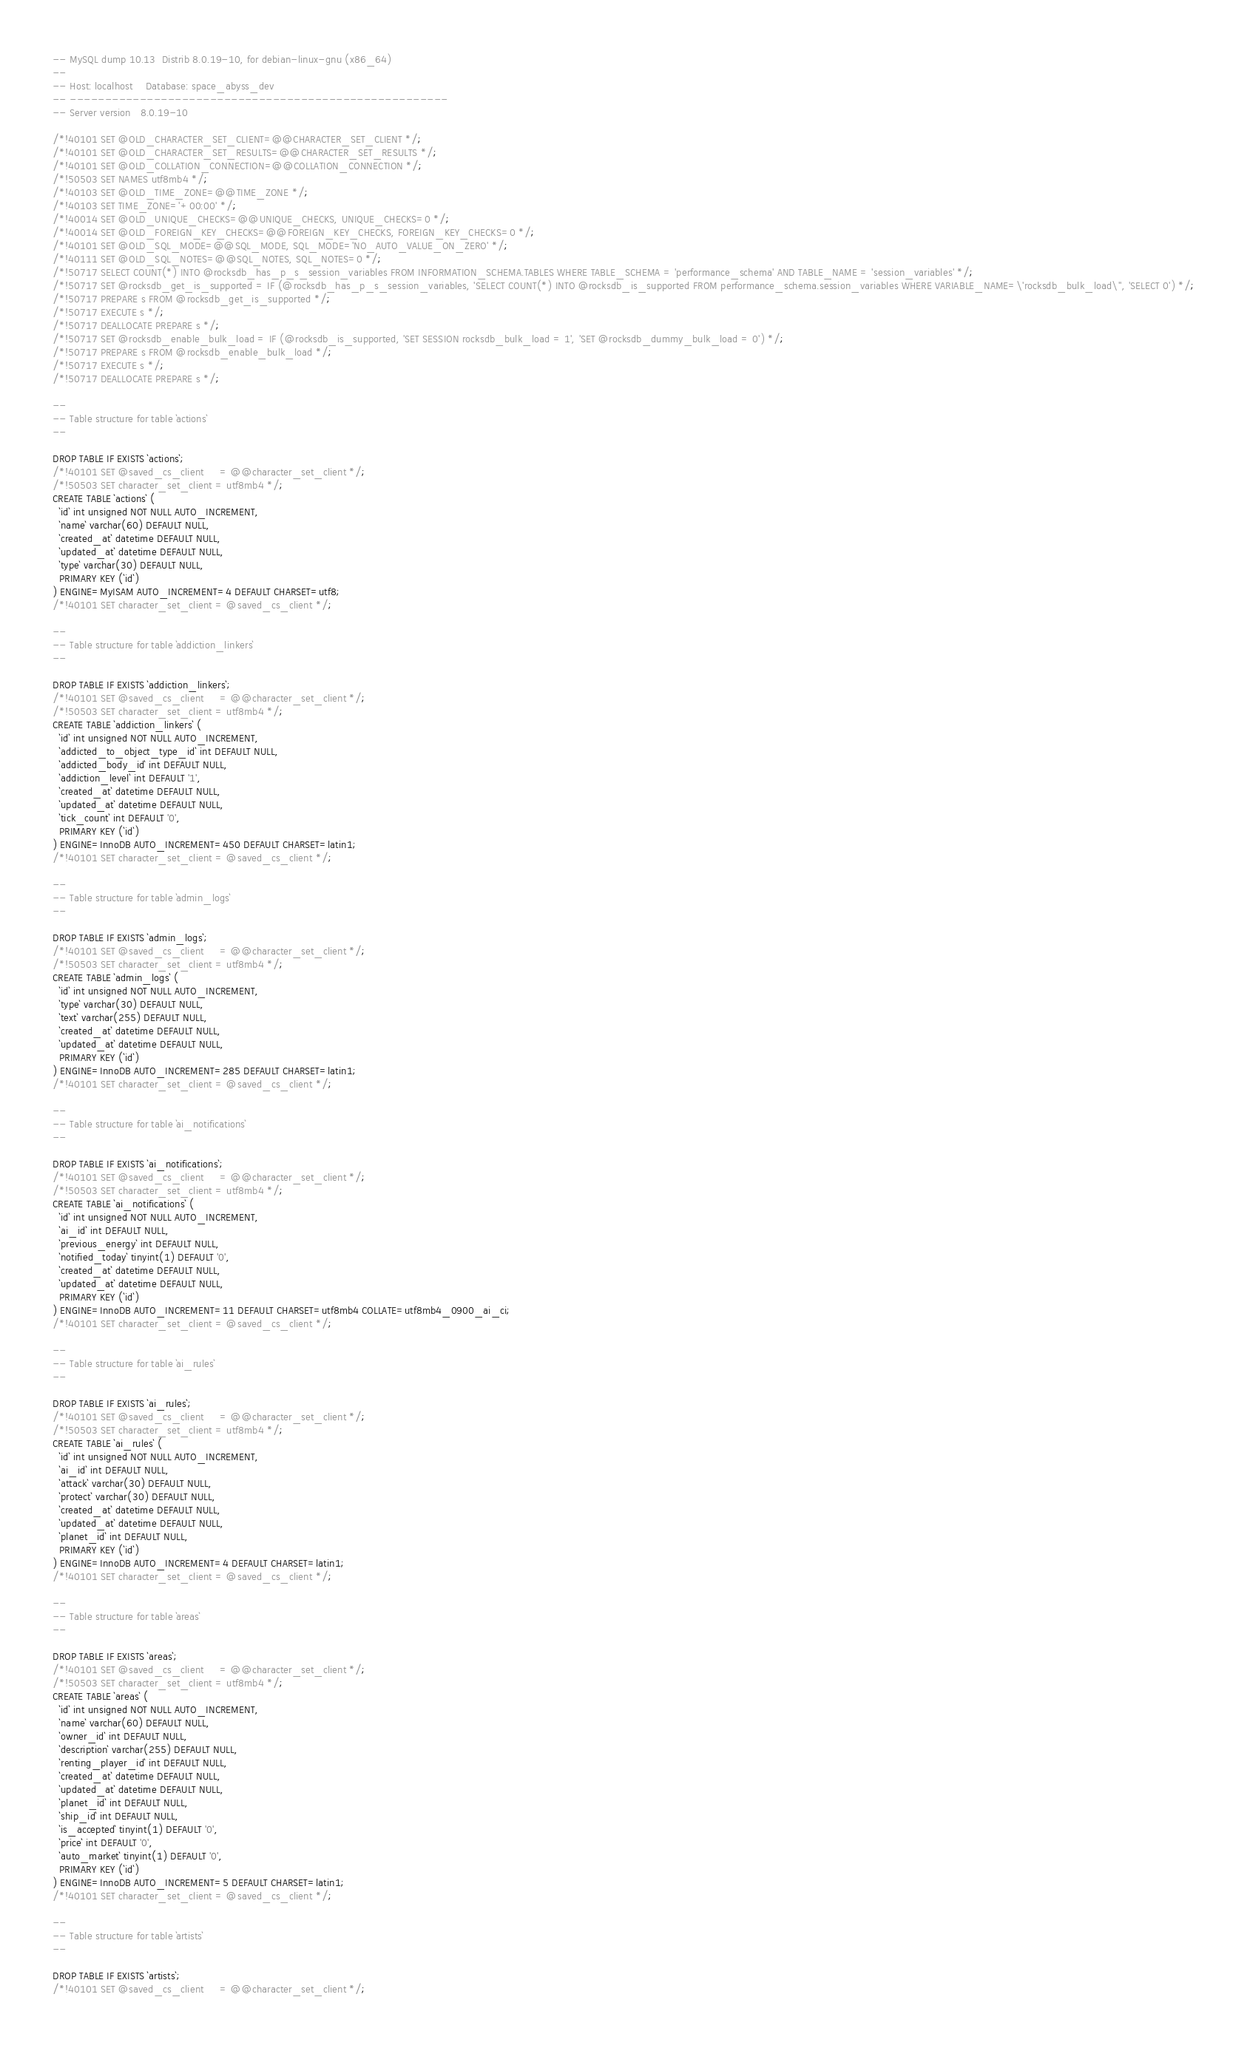<code> <loc_0><loc_0><loc_500><loc_500><_SQL_>-- MySQL dump 10.13  Distrib 8.0.19-10, for debian-linux-gnu (x86_64)
--
-- Host: localhost    Database: space_abyss_dev
-- ------------------------------------------------------
-- Server version	8.0.19-10

/*!40101 SET @OLD_CHARACTER_SET_CLIENT=@@CHARACTER_SET_CLIENT */;
/*!40101 SET @OLD_CHARACTER_SET_RESULTS=@@CHARACTER_SET_RESULTS */;
/*!40101 SET @OLD_COLLATION_CONNECTION=@@COLLATION_CONNECTION */;
/*!50503 SET NAMES utf8mb4 */;
/*!40103 SET @OLD_TIME_ZONE=@@TIME_ZONE */;
/*!40103 SET TIME_ZONE='+00:00' */;
/*!40014 SET @OLD_UNIQUE_CHECKS=@@UNIQUE_CHECKS, UNIQUE_CHECKS=0 */;
/*!40014 SET @OLD_FOREIGN_KEY_CHECKS=@@FOREIGN_KEY_CHECKS, FOREIGN_KEY_CHECKS=0 */;
/*!40101 SET @OLD_SQL_MODE=@@SQL_MODE, SQL_MODE='NO_AUTO_VALUE_ON_ZERO' */;
/*!40111 SET @OLD_SQL_NOTES=@@SQL_NOTES, SQL_NOTES=0 */;
/*!50717 SELECT COUNT(*) INTO @rocksdb_has_p_s_session_variables FROM INFORMATION_SCHEMA.TABLES WHERE TABLE_SCHEMA = 'performance_schema' AND TABLE_NAME = 'session_variables' */;
/*!50717 SET @rocksdb_get_is_supported = IF (@rocksdb_has_p_s_session_variables, 'SELECT COUNT(*) INTO @rocksdb_is_supported FROM performance_schema.session_variables WHERE VARIABLE_NAME=\'rocksdb_bulk_load\'', 'SELECT 0') */;
/*!50717 PREPARE s FROM @rocksdb_get_is_supported */;
/*!50717 EXECUTE s */;
/*!50717 DEALLOCATE PREPARE s */;
/*!50717 SET @rocksdb_enable_bulk_load = IF (@rocksdb_is_supported, 'SET SESSION rocksdb_bulk_load = 1', 'SET @rocksdb_dummy_bulk_load = 0') */;
/*!50717 PREPARE s FROM @rocksdb_enable_bulk_load */;
/*!50717 EXECUTE s */;
/*!50717 DEALLOCATE PREPARE s */;

--
-- Table structure for table `actions`
--

DROP TABLE IF EXISTS `actions`;
/*!40101 SET @saved_cs_client     = @@character_set_client */;
/*!50503 SET character_set_client = utf8mb4 */;
CREATE TABLE `actions` (
  `id` int unsigned NOT NULL AUTO_INCREMENT,
  `name` varchar(60) DEFAULT NULL,
  `created_at` datetime DEFAULT NULL,
  `updated_at` datetime DEFAULT NULL,
  `type` varchar(30) DEFAULT NULL,
  PRIMARY KEY (`id`)
) ENGINE=MyISAM AUTO_INCREMENT=4 DEFAULT CHARSET=utf8;
/*!40101 SET character_set_client = @saved_cs_client */;

--
-- Table structure for table `addiction_linkers`
--

DROP TABLE IF EXISTS `addiction_linkers`;
/*!40101 SET @saved_cs_client     = @@character_set_client */;
/*!50503 SET character_set_client = utf8mb4 */;
CREATE TABLE `addiction_linkers` (
  `id` int unsigned NOT NULL AUTO_INCREMENT,
  `addicted_to_object_type_id` int DEFAULT NULL,
  `addicted_body_id` int DEFAULT NULL,
  `addiction_level` int DEFAULT '1',
  `created_at` datetime DEFAULT NULL,
  `updated_at` datetime DEFAULT NULL,
  `tick_count` int DEFAULT '0',
  PRIMARY KEY (`id`)
) ENGINE=InnoDB AUTO_INCREMENT=450 DEFAULT CHARSET=latin1;
/*!40101 SET character_set_client = @saved_cs_client */;

--
-- Table structure for table `admin_logs`
--

DROP TABLE IF EXISTS `admin_logs`;
/*!40101 SET @saved_cs_client     = @@character_set_client */;
/*!50503 SET character_set_client = utf8mb4 */;
CREATE TABLE `admin_logs` (
  `id` int unsigned NOT NULL AUTO_INCREMENT,
  `type` varchar(30) DEFAULT NULL,
  `text` varchar(255) DEFAULT NULL,
  `created_at` datetime DEFAULT NULL,
  `updated_at` datetime DEFAULT NULL,
  PRIMARY KEY (`id`)
) ENGINE=InnoDB AUTO_INCREMENT=285 DEFAULT CHARSET=latin1;
/*!40101 SET character_set_client = @saved_cs_client */;

--
-- Table structure for table `ai_notifications`
--

DROP TABLE IF EXISTS `ai_notifications`;
/*!40101 SET @saved_cs_client     = @@character_set_client */;
/*!50503 SET character_set_client = utf8mb4 */;
CREATE TABLE `ai_notifications` (
  `id` int unsigned NOT NULL AUTO_INCREMENT,
  `ai_id` int DEFAULT NULL,
  `previous_energy` int DEFAULT NULL,
  `notified_today` tinyint(1) DEFAULT '0',
  `created_at` datetime DEFAULT NULL,
  `updated_at` datetime DEFAULT NULL,
  PRIMARY KEY (`id`)
) ENGINE=InnoDB AUTO_INCREMENT=11 DEFAULT CHARSET=utf8mb4 COLLATE=utf8mb4_0900_ai_ci;
/*!40101 SET character_set_client = @saved_cs_client */;

--
-- Table structure for table `ai_rules`
--

DROP TABLE IF EXISTS `ai_rules`;
/*!40101 SET @saved_cs_client     = @@character_set_client */;
/*!50503 SET character_set_client = utf8mb4 */;
CREATE TABLE `ai_rules` (
  `id` int unsigned NOT NULL AUTO_INCREMENT,
  `ai_id` int DEFAULT NULL,
  `attack` varchar(30) DEFAULT NULL,
  `protect` varchar(30) DEFAULT NULL,
  `created_at` datetime DEFAULT NULL,
  `updated_at` datetime DEFAULT NULL,
  `planet_id` int DEFAULT NULL,
  PRIMARY KEY (`id`)
) ENGINE=InnoDB AUTO_INCREMENT=4 DEFAULT CHARSET=latin1;
/*!40101 SET character_set_client = @saved_cs_client */;

--
-- Table structure for table `areas`
--

DROP TABLE IF EXISTS `areas`;
/*!40101 SET @saved_cs_client     = @@character_set_client */;
/*!50503 SET character_set_client = utf8mb4 */;
CREATE TABLE `areas` (
  `id` int unsigned NOT NULL AUTO_INCREMENT,
  `name` varchar(60) DEFAULT NULL,
  `owner_id` int DEFAULT NULL,
  `description` varchar(255) DEFAULT NULL,
  `renting_player_id` int DEFAULT NULL,
  `created_at` datetime DEFAULT NULL,
  `updated_at` datetime DEFAULT NULL,
  `planet_id` int DEFAULT NULL,
  `ship_id` int DEFAULT NULL,
  `is_accepted` tinyint(1) DEFAULT '0',
  `price` int DEFAULT '0',
  `auto_market` tinyint(1) DEFAULT '0',
  PRIMARY KEY (`id`)
) ENGINE=InnoDB AUTO_INCREMENT=5 DEFAULT CHARSET=latin1;
/*!40101 SET character_set_client = @saved_cs_client */;

--
-- Table structure for table `artists`
--

DROP TABLE IF EXISTS `artists`;
/*!40101 SET @saved_cs_client     = @@character_set_client */;</code> 